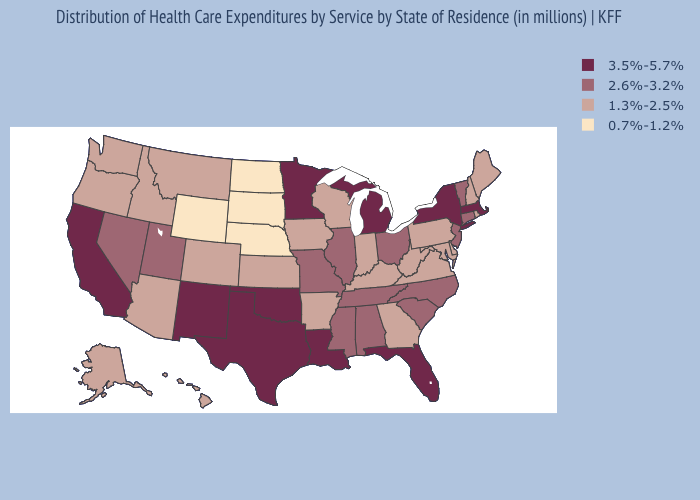How many symbols are there in the legend?
Write a very short answer. 4. What is the value of Texas?
Answer briefly. 3.5%-5.7%. Name the states that have a value in the range 1.3%-2.5%?
Concise answer only. Alaska, Arizona, Arkansas, Colorado, Delaware, Georgia, Hawaii, Idaho, Indiana, Iowa, Kansas, Kentucky, Maine, Maryland, Montana, New Hampshire, Oregon, Pennsylvania, Rhode Island, Virginia, Washington, West Virginia, Wisconsin. Does Wyoming have the lowest value in the West?
Short answer required. Yes. Does New Mexico have the highest value in the West?
Quick response, please. Yes. Name the states that have a value in the range 0.7%-1.2%?
Keep it brief. Nebraska, North Dakota, South Dakota, Wyoming. Does South Carolina have the lowest value in the South?
Concise answer only. No. Name the states that have a value in the range 3.5%-5.7%?
Quick response, please. California, Florida, Louisiana, Massachusetts, Michigan, Minnesota, New Mexico, New York, Oklahoma, Texas. Which states have the lowest value in the West?
Quick response, please. Wyoming. What is the value of North Dakota?
Give a very brief answer. 0.7%-1.2%. Does Maryland have a higher value than North Dakota?
Answer briefly. Yes. What is the value of New Hampshire?
Write a very short answer. 1.3%-2.5%. Name the states that have a value in the range 2.6%-3.2%?
Quick response, please. Alabama, Connecticut, Illinois, Mississippi, Missouri, Nevada, New Jersey, North Carolina, Ohio, South Carolina, Tennessee, Utah, Vermont. What is the value of Hawaii?
Give a very brief answer. 1.3%-2.5%. What is the value of Vermont?
Write a very short answer. 2.6%-3.2%. 